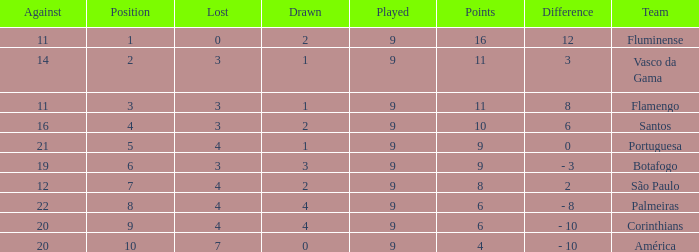Which Position has a Played larger than 9? None. 